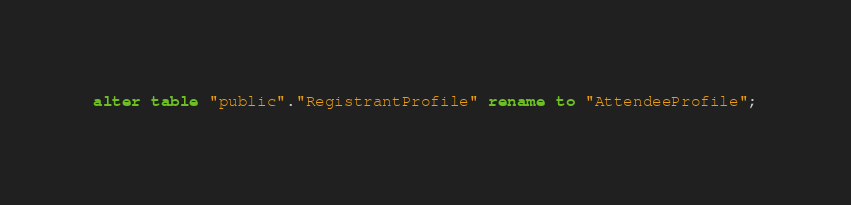<code> <loc_0><loc_0><loc_500><loc_500><_SQL_>alter table "public"."RegistrantProfile" rename to "AttendeeProfile";
</code> 